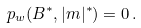Convert formula to latex. <formula><loc_0><loc_0><loc_500><loc_500>p _ { w } ( B ^ { * } , | m | ^ { * } ) = 0 \, .</formula> 